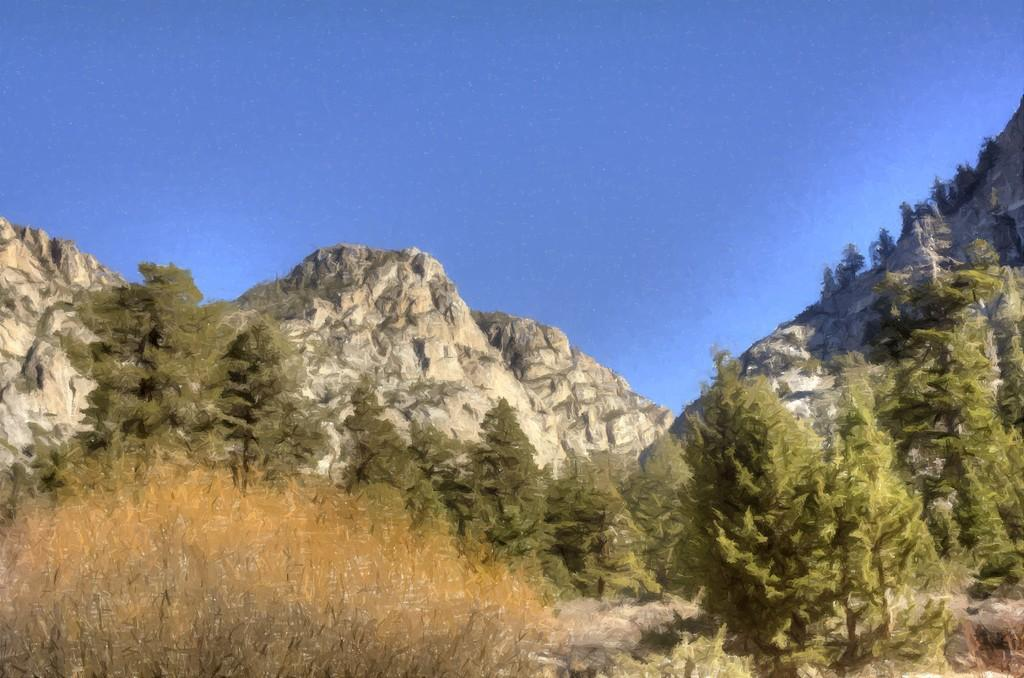Where was the image taken? The image was taken outdoors. What can be seen at the top of the image? The sky is visible at the top of the image. What is present at the bottom of the image? There are plants at the bottom of the image. What can be observed in the background of the image? There are many trees and a few hills in the background of the image. How many goldfish are swimming in the pond in the image? There is no pond or goldfish present in the image. What type of quiver is being used by the person in the image? There is no person or quiver present in the image. 